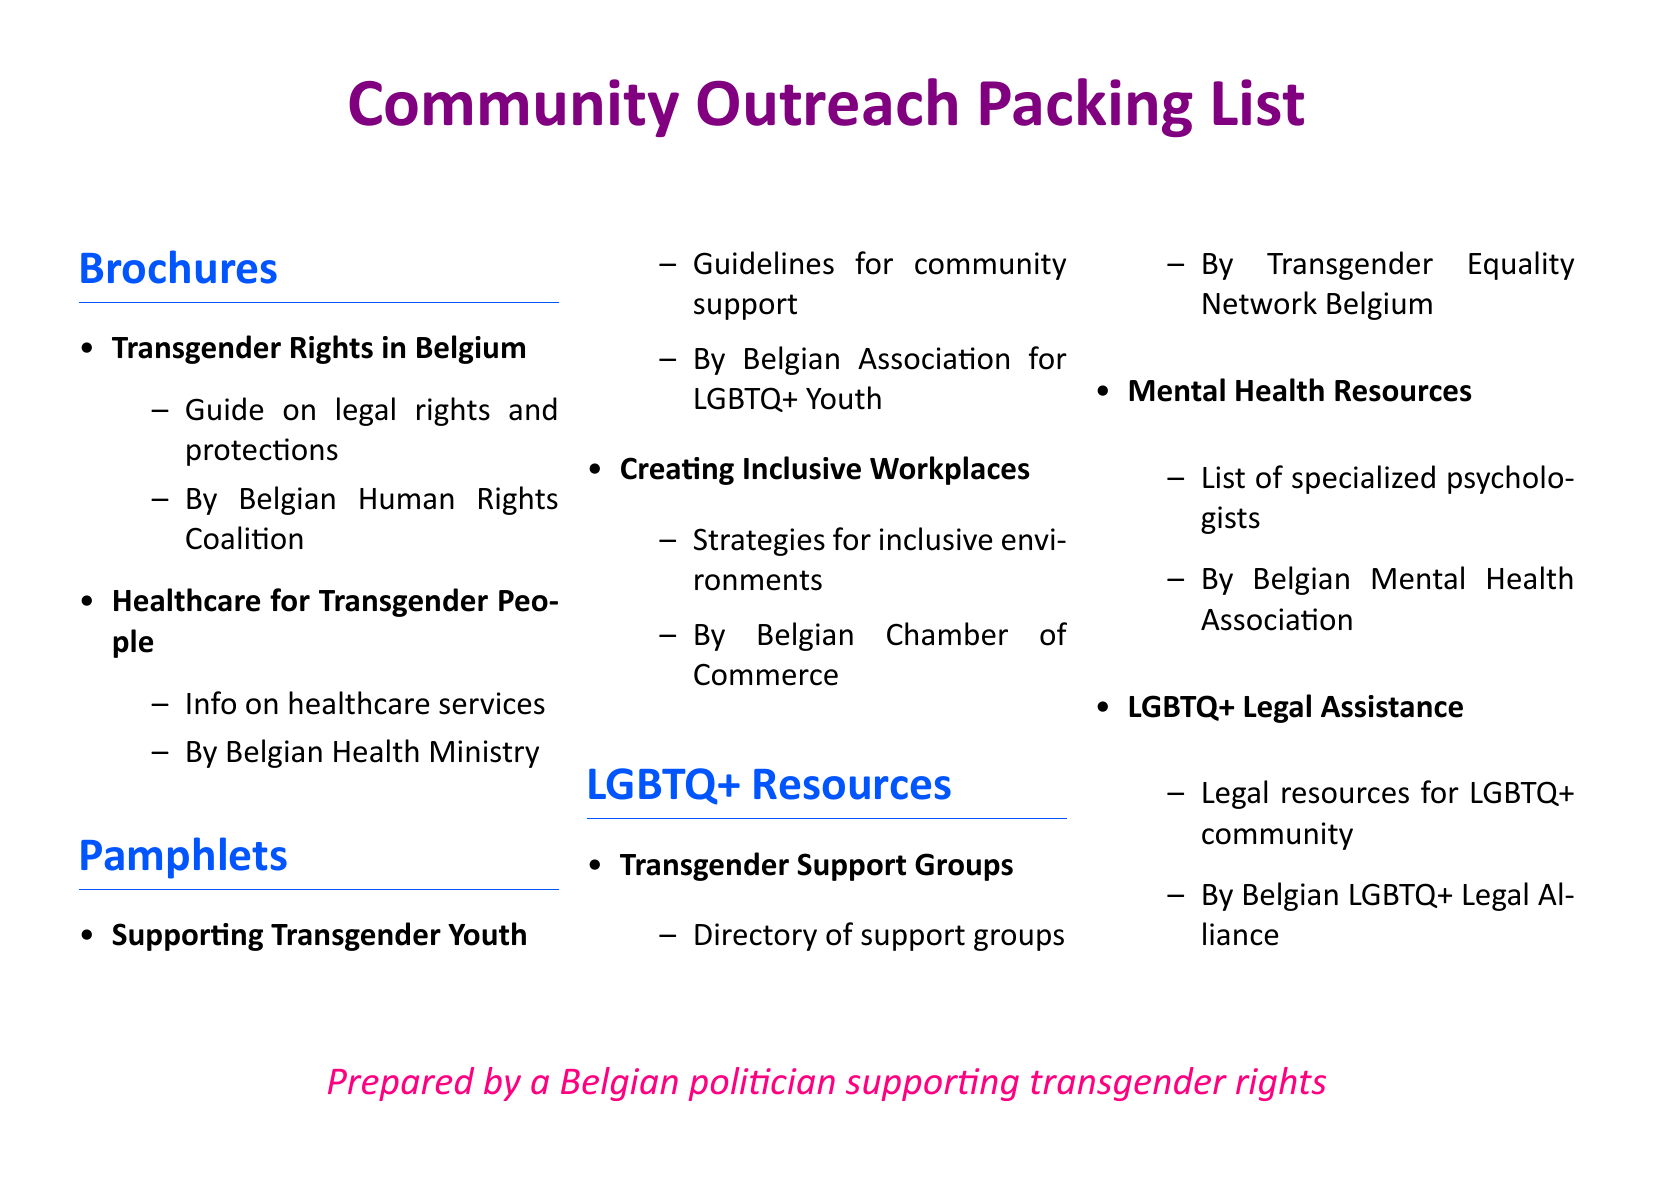What are the titles of two brochures listed? The titles of the brochures include "Transgender Rights in Belgium" and "Healthcare for Transgender People."
Answer: "Transgender Rights in Belgium", "Healthcare for Transgender People" Who prepared the document? The document is prepared by a Belgian politician supporting transgender rights.
Answer: A Belgian politician supporting transgender rights How many pamphlets are listed? There are two pamphlets mentioned in the document: "Supporting Transgender Youth" and "Creating Inclusive Workplaces."
Answer: 2 What organization provided the "Mental Health Resources"? The "Mental Health Resources" were provided by the Belgian Mental Health Association.
Answer: Belgian Mental Health Association What is the primary focus of the pamphlet by the Belgian Association for LGBTQ+ Youth? The primary focus of the pamphlet is to provide guidelines for community support for transgender youth.
Answer: Supporting Transgender Youth What kind of directory does the "Transgender Support Groups" resource include? It includes a directory of support groups for transgender individuals.
Answer: Directory of support groups What color is the header for the title of the document? The header color for the title of the document is lgbtpurple.
Answer: lgbtpurple What is the purpose of the document? The purpose is to outline community outreach material distribution for LGBTQ+ resources.
Answer: Community outreach material distribution 